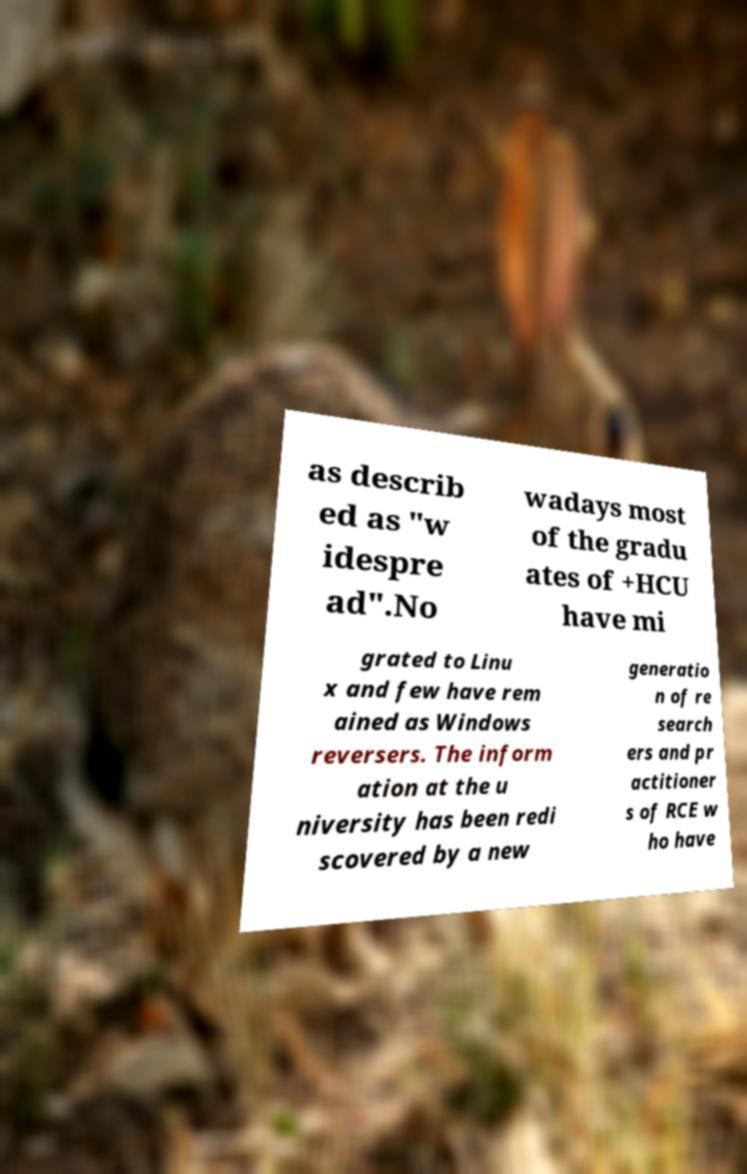Please identify and transcribe the text found in this image. as describ ed as "w idespre ad".No wadays most of the gradu ates of +HCU have mi grated to Linu x and few have rem ained as Windows reversers. The inform ation at the u niversity has been redi scovered by a new generatio n of re search ers and pr actitioner s of RCE w ho have 